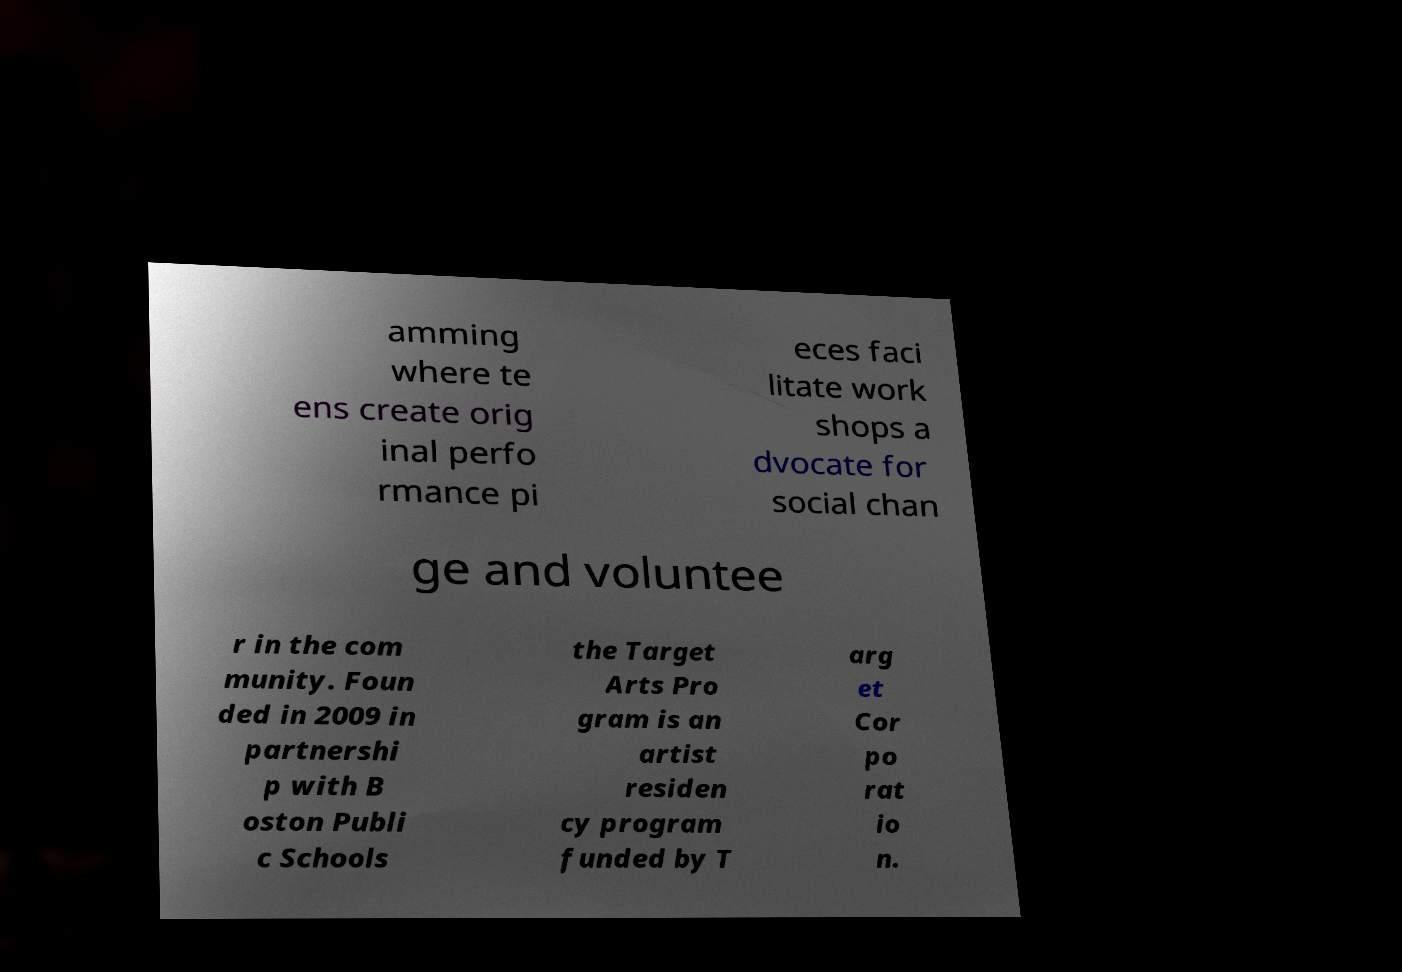Can you read and provide the text displayed in the image?This photo seems to have some interesting text. Can you extract and type it out for me? amming where te ens create orig inal perfo rmance pi eces faci litate work shops a dvocate for social chan ge and voluntee r in the com munity. Foun ded in 2009 in partnershi p with B oston Publi c Schools the Target Arts Pro gram is an artist residen cy program funded by T arg et Cor po rat io n. 